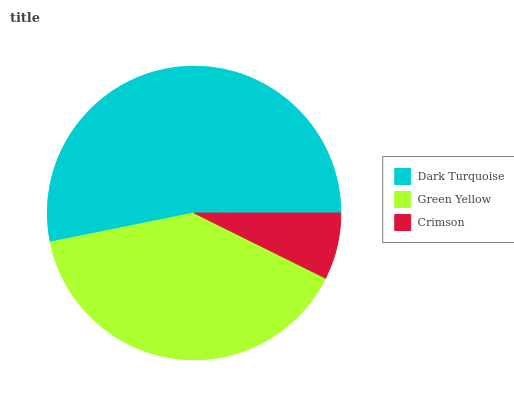Is Crimson the minimum?
Answer yes or no. Yes. Is Dark Turquoise the maximum?
Answer yes or no. Yes. Is Green Yellow the minimum?
Answer yes or no. No. Is Green Yellow the maximum?
Answer yes or no. No. Is Dark Turquoise greater than Green Yellow?
Answer yes or no. Yes. Is Green Yellow less than Dark Turquoise?
Answer yes or no. Yes. Is Green Yellow greater than Dark Turquoise?
Answer yes or no. No. Is Dark Turquoise less than Green Yellow?
Answer yes or no. No. Is Green Yellow the high median?
Answer yes or no. Yes. Is Green Yellow the low median?
Answer yes or no. Yes. Is Crimson the high median?
Answer yes or no. No. Is Crimson the low median?
Answer yes or no. No. 